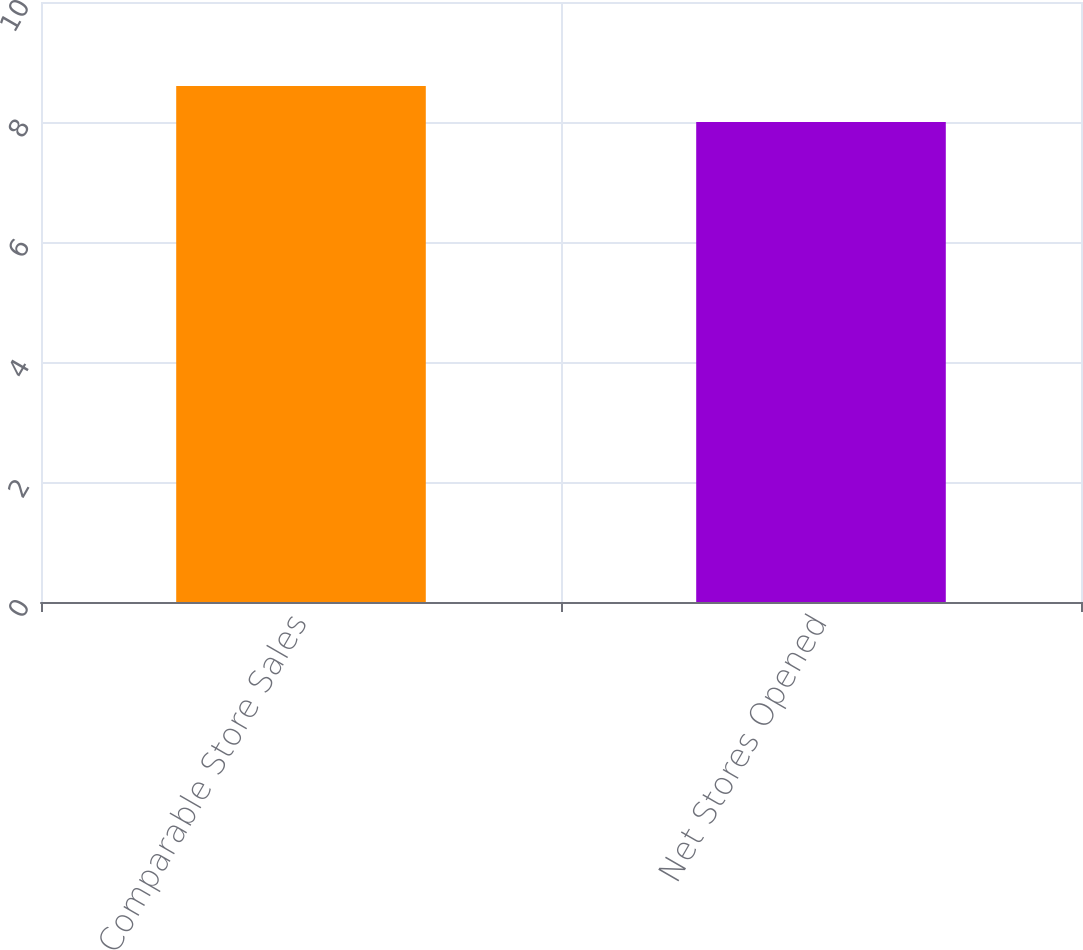Convert chart to OTSL. <chart><loc_0><loc_0><loc_500><loc_500><bar_chart><fcel>Comparable Store Sales<fcel>Net Stores Opened<nl><fcel>8.6<fcel>8<nl></chart> 